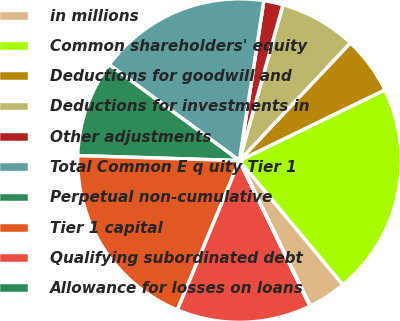Convert chart to OTSL. <chart><loc_0><loc_0><loc_500><loc_500><pie_chart><fcel>in millions<fcel>Common shareholders' equity<fcel>Deductions for goodwill and<fcel>Deductions for investments in<fcel>Other adjustments<fcel>Total Common E q uity Tier 1<fcel>Perpetual non-cumulative<fcel>Tier 1 capital<fcel>Qualifying subordinated debt<fcel>Allowance for losses on loans<nl><fcel>3.85%<fcel>21.14%<fcel>5.77%<fcel>7.69%<fcel>1.93%<fcel>17.3%<fcel>9.62%<fcel>19.22%<fcel>13.46%<fcel>0.01%<nl></chart> 